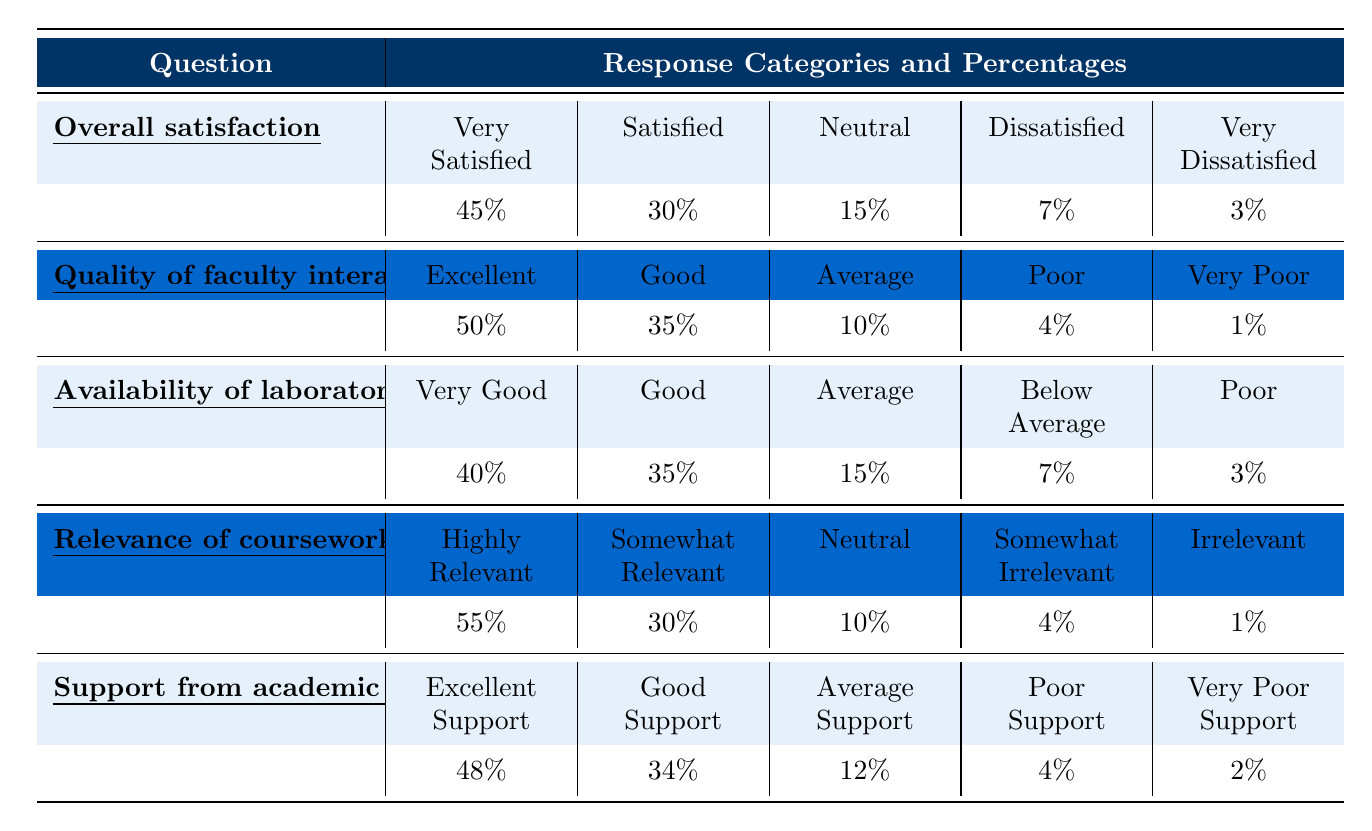What percentage of students are either very satisfied or satisfied with the overall program? To find this, we add the percentages of "Very Satisfied" (45%) and "Satisfied" (30%). Hence, 45% + 30% = 75%.
Answer: 75% What is the percentage of students that have a neutral opinion about the quality of faculty interactions? The table shows that the percentage for "Average" in faculty interactions is 10%, which represents a neutral opinion.
Answer: 10% What is the highest percentage of responses for the relevance of coursework to future careers? The highest percentage in the category of relevance is "Highly Relevant" at 55%.
Answer: 55% Is the support from academic advisors rated as excellent by more than 50% of the respondents? The percentage for "Excellent Support" is 48%, which is less than 50%, therefore the statement is false.
Answer: No What is the combined percentage of students who either rated the availability of laboratory resources as "Good" or "Very Good"? We will add the percentages for "Very Good" (40%) and "Good" (35%): 40% + 35% = 75%.
Answer: 75% If 100 students participated in the survey, how many students rated the quality of faculty interactions as either "Excellent" or "Good"? To find this, calculate 50% (Excellent) + 35% (Good), which gives us 85% of 100 students. Therefore, 0.85 * 100 = 85 students.
Answer: 85 What percentage of students found the available laboratory resources as either below average or poor? We add the percentages for "Below Average" (7%) and "Poor" (3%). Thus, 7% + 3% = 10%.
Answer: 10% Which category for support from academic advisors has the lowest percentage and what is that percentage? The lowest rating in the support category is "Very Poor Support" at 2%.
Answer: 2% What is the percentage difference between students who rated faculty interactions as "Excellent" and those who rated it as "Very Poor"? The difference is calculated as 50% (Excellent) - 1% (Very Poor) = 49%.
Answer: 49% What fraction of students rated the relevance of coursework as either somewhat relevant or irrelevant? The percentages for "Somewhat Relevant" (30%) and "Irrelevant" (1%) total to 31%. Thus, 31% represents the fraction.
Answer: 31% 